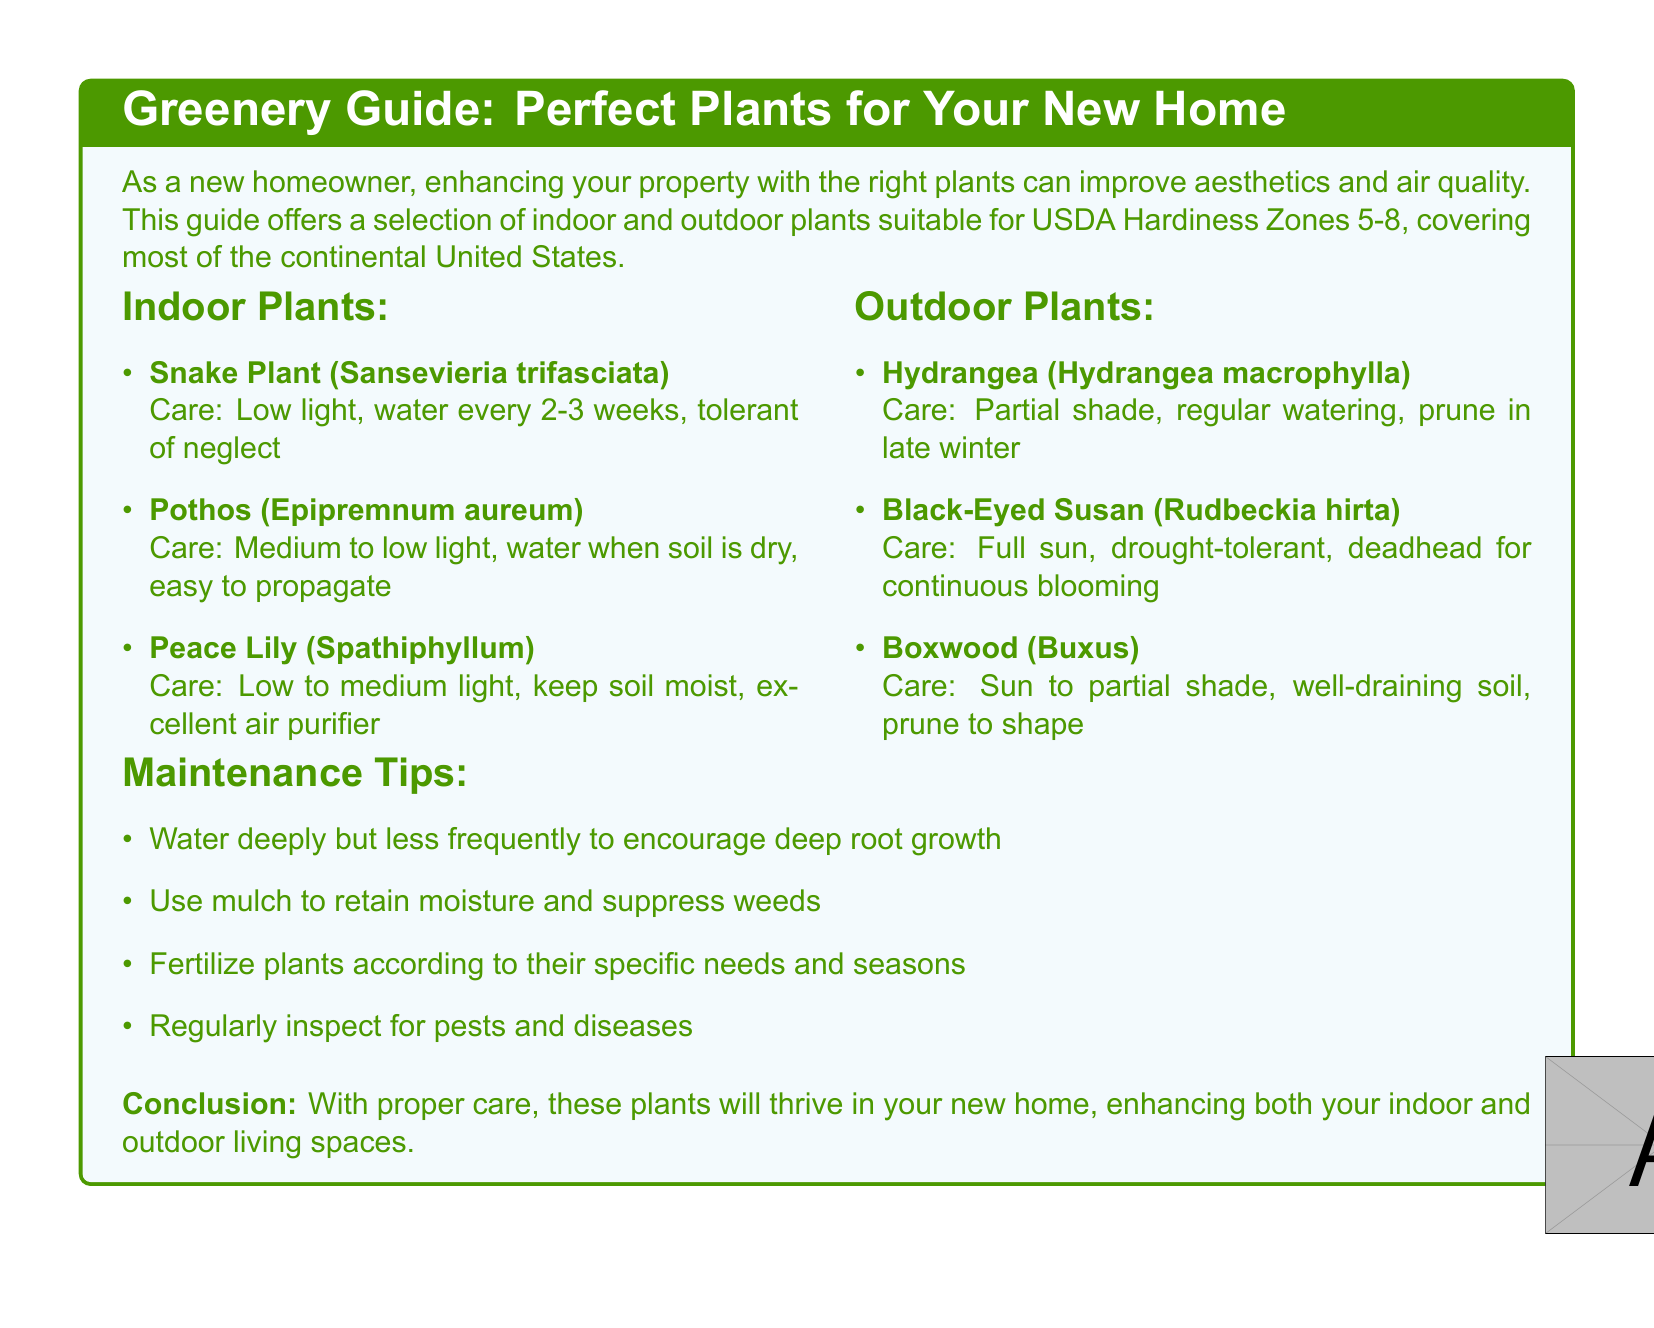What type of indoor plant is easy to propagate? The document lists Pothos as an indoor plant that is easy to propagate.
Answer: Pothos How often should you water the Snake Plant? According to the care instructions, the Snake Plant should be watered every 2-3 weeks.
Answer: every 2-3 weeks What is the light requirement for Peace Lily? Peace Lily requires low to medium light.
Answer: low to medium light What care does Black-Eyed Susan require? Black-Eyed Susan requires full sun and is drought-tolerant as per the outdoor plant care instructions.
Answer: Full sun, drought-tolerant How should outdoor plants be pruned? The document states that outdoor plants should be pruned to shape, particularly noting Boxwood requires pruning.
Answer: Prune to shape What maintenance tip encourages deep root growth? The document suggests watering deeply but less frequently to encourage deep root growth.
Answer: Water deeply but less frequently Which USDA Hardiness Zones are covered in this guide? The guide covers USDA Hardiness Zones 5-8.
Answer: Zones 5-8 What type of document is this? The document is a catalog focused on a selection of indoor and outdoor plants with care instructions.
Answer: Catalog 